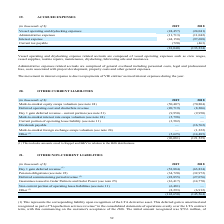From Golar Lng's financial document, What are the segments of accrued expenses? The document contains multiple relevant values: Vessel operating and drydocking expenses, Administrative expenses, Interest expense, Current tax payable. From the document: "(in thousands of $) 2019 2018 Vessel operating and drydocking expenses (24,457) (24,041) Administrative expenses (11,713) (11,042) Interest expense (4..." Also, What does administrative expenses represent? comprised of general overhead including personnel costs, legal and professional fees, costs associated with project development, property costs and other general expenses. The document states: "Administrative expenses related accruals are comprised of general overhead including personnel costs, legal and professional fees, costs associated wi..." Also, What accounted for the movement in interest expense? Due to repayments of VIE entities' accrued interest expenses during the year.. The document states: "The movement in interest expense is due to repayments of VIE entities' accrued interest expenses during the year...." Additionally, Which year has a higher interest expense? According to the financial document, 2018. The relevant text states: "(in thousands of $) 2019 2018 Vessel operating and drydocking expenses (24,457) (24,041) Administrative expenses (11,713) (11,042..." Also, can you calculate: What was the change in administrative expense between 2018 and 2019? Based on the calculation: (11,713) - (11,042) , the result is -671 (in thousands). This is based on the information: "penses (24,457) (24,041) Administrative expenses (11,713) (11,042) Interest expense (44,150) (97,688) Current tax payable (720) (463) (81,040) (133,234) 4,457) (24,041) Administrative expenses (11,713..." The key data points involved are: 11,042, 11,713. Also, can you calculate: What was the percentage change in current tax payable between 2018 and 2019? To answer this question, I need to perform calculations using the financial data. The calculation is: (720-463)/463, which equals 55.51 (percentage). This is based on the information: "st expense (44,150) (97,688) Current tax payable (720) (463) (81,040) (133,234) ense (44,150) (97,688) Current tax payable (720) (463) (81,040) (133,234)..." The key data points involved are: 463, 720. 